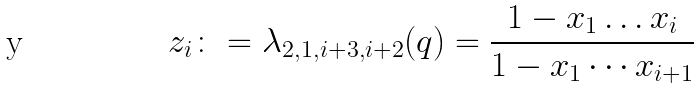<formula> <loc_0><loc_0><loc_500><loc_500>z _ { i } \colon = \lambda _ { 2 , 1 , i + 3 , i + 2 } ( q ) = \frac { 1 - x _ { 1 } \dots x _ { i } } { 1 - x _ { 1 } \cdots x _ { i + 1 } }</formula> 